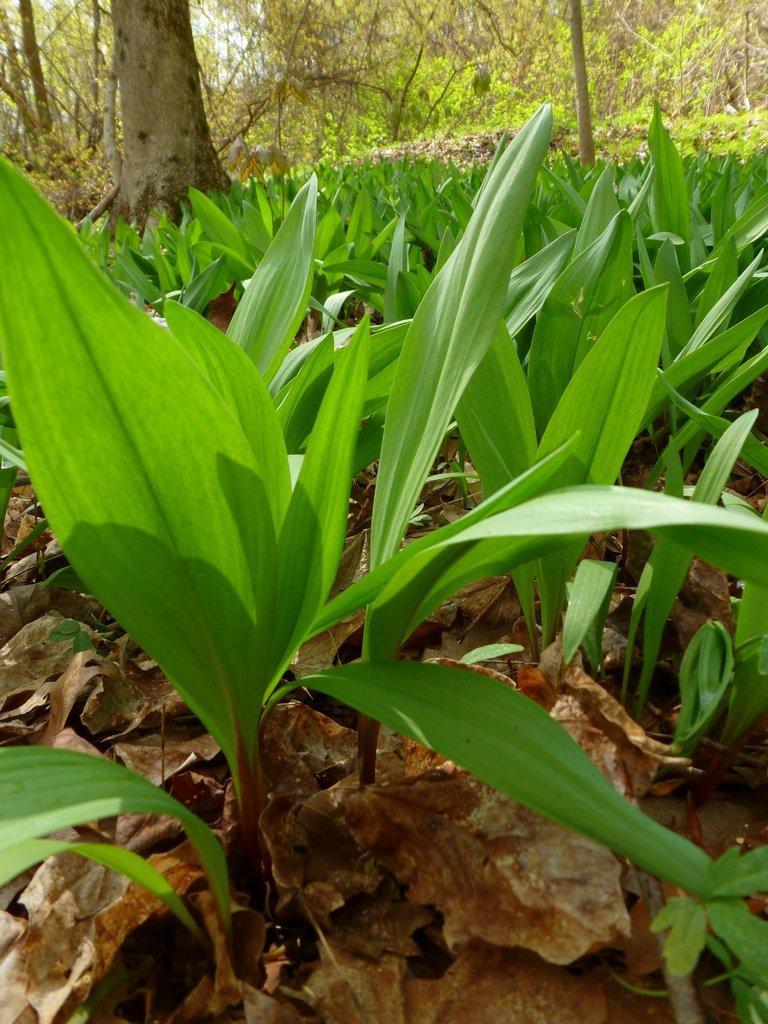How would you summarize this image in a sentence or two? In this image I can see plants. There are trees and also there are dried leaves on the ground. 